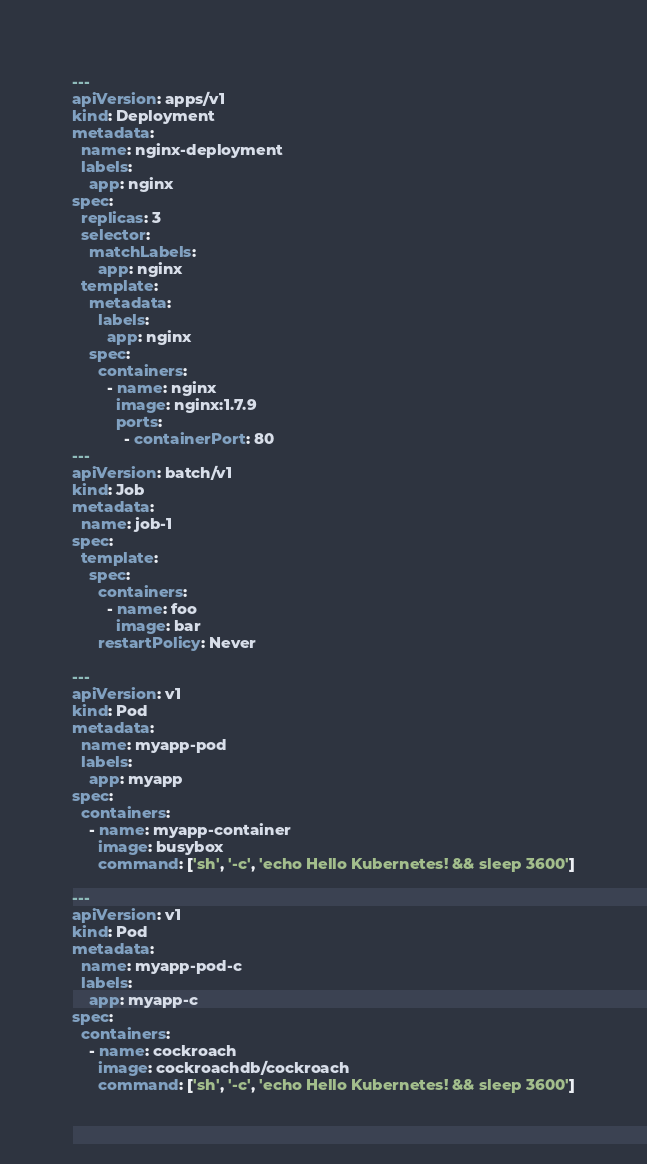Convert code to text. <code><loc_0><loc_0><loc_500><loc_500><_YAML_>---
apiVersion: apps/v1
kind: Deployment
metadata:
  name: nginx-deployment
  labels:
    app: nginx
spec:
  replicas: 3
  selector:
    matchLabels:
      app: nginx
  template:
    metadata:
      labels:
        app: nginx
    spec:
      containers:
        - name: nginx
          image: nginx:1.7.9
          ports:
            - containerPort: 80
---
apiVersion: batch/v1
kind: Job
metadata:
  name: job-1
spec:
  template:
    spec:
      containers:
        - name: foo
          image: bar
      restartPolicy: Never

---
apiVersion: v1
kind: Pod
metadata:
  name: myapp-pod
  labels:
    app: myapp
spec:
  containers:
    - name: myapp-container
      image: busybox
      command: ['sh', '-c', 'echo Hello Kubernetes! && sleep 3600']

---
apiVersion: v1
kind: Pod
metadata:
  name: myapp-pod-c
  labels:
    app: myapp-c
spec:
  containers:
    - name: cockroach
      image: cockroachdb/cockroach
      command: ['sh', '-c', 'echo Hello Kubernetes! && sleep 3600']
</code> 